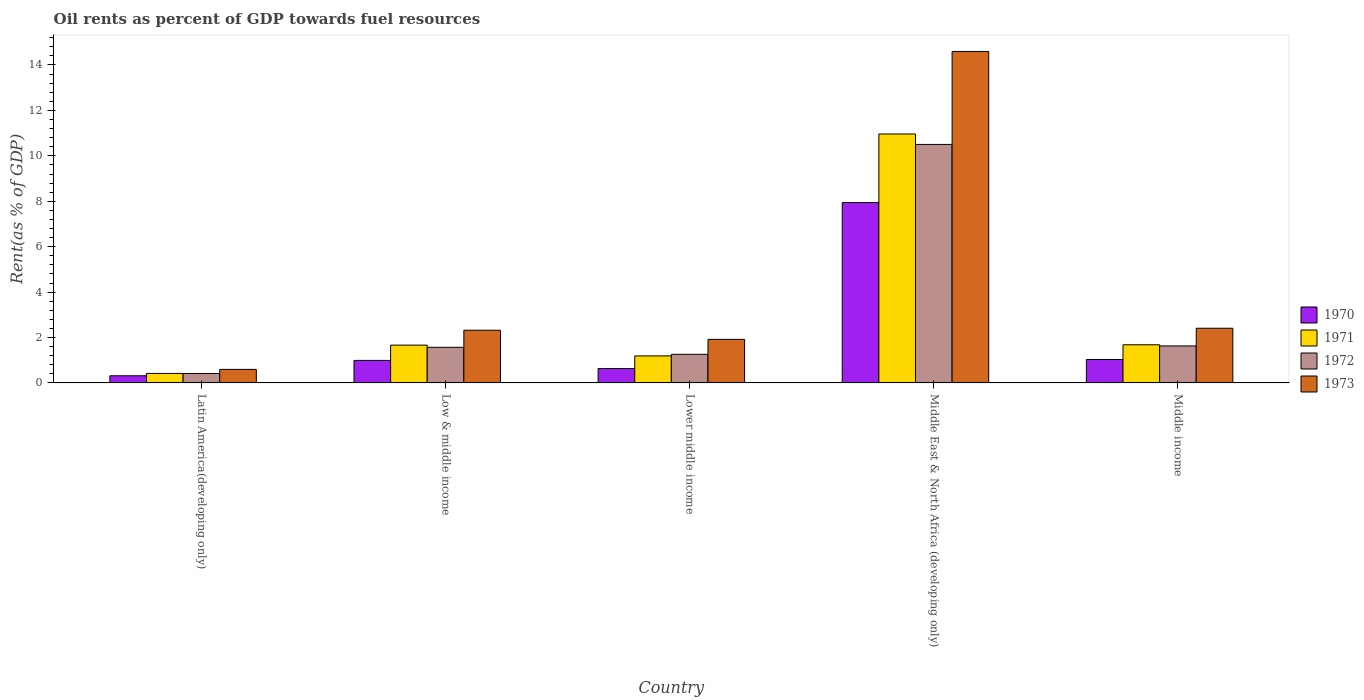Are the number of bars on each tick of the X-axis equal?
Offer a very short reply. Yes. How many bars are there on the 4th tick from the left?
Your answer should be compact. 4. How many bars are there on the 1st tick from the right?
Your response must be concise. 4. What is the oil rent in 1972 in Middle income?
Offer a terse response. 1.63. Across all countries, what is the maximum oil rent in 1971?
Your response must be concise. 10.96. Across all countries, what is the minimum oil rent in 1972?
Offer a very short reply. 0.42. In which country was the oil rent in 1973 maximum?
Your answer should be very brief. Middle East & North Africa (developing only). In which country was the oil rent in 1972 minimum?
Your answer should be compact. Latin America(developing only). What is the total oil rent in 1973 in the graph?
Provide a succinct answer. 21.84. What is the difference between the oil rent in 1970 in Latin America(developing only) and that in Middle East & North Africa (developing only)?
Your answer should be compact. -7.63. What is the difference between the oil rent in 1970 in Latin America(developing only) and the oil rent in 1971 in Low & middle income?
Your response must be concise. -1.35. What is the average oil rent in 1972 per country?
Your answer should be compact. 3.08. What is the difference between the oil rent of/in 1971 and oil rent of/in 1973 in Middle income?
Your response must be concise. -0.73. In how many countries, is the oil rent in 1971 greater than 1.2000000000000002 %?
Your answer should be very brief. 3. What is the ratio of the oil rent in 1973 in Lower middle income to that in Middle income?
Your answer should be very brief. 0.8. Is the oil rent in 1972 in Low & middle income less than that in Lower middle income?
Offer a terse response. No. What is the difference between the highest and the second highest oil rent in 1972?
Make the answer very short. -8.87. What is the difference between the highest and the lowest oil rent in 1972?
Offer a very short reply. 10.09. In how many countries, is the oil rent in 1973 greater than the average oil rent in 1973 taken over all countries?
Keep it short and to the point. 1. What does the 3rd bar from the left in Latin America(developing only) represents?
Ensure brevity in your answer.  1972. What does the 1st bar from the right in Middle income represents?
Offer a terse response. 1973. How many bars are there?
Offer a very short reply. 20. Are all the bars in the graph horizontal?
Offer a terse response. No. How many countries are there in the graph?
Provide a short and direct response. 5. What is the difference between two consecutive major ticks on the Y-axis?
Provide a succinct answer. 2. Does the graph contain any zero values?
Keep it short and to the point. No. How many legend labels are there?
Offer a terse response. 4. How are the legend labels stacked?
Provide a succinct answer. Vertical. What is the title of the graph?
Offer a terse response. Oil rents as percent of GDP towards fuel resources. What is the label or title of the Y-axis?
Provide a short and direct response. Rent(as % of GDP). What is the Rent(as % of GDP) of 1970 in Latin America(developing only)?
Ensure brevity in your answer.  0.32. What is the Rent(as % of GDP) in 1971 in Latin America(developing only)?
Provide a short and direct response. 0.42. What is the Rent(as % of GDP) of 1972 in Latin America(developing only)?
Your answer should be compact. 0.42. What is the Rent(as % of GDP) in 1973 in Latin America(developing only)?
Your answer should be compact. 0.6. What is the Rent(as % of GDP) in 1970 in Low & middle income?
Your response must be concise. 0.99. What is the Rent(as % of GDP) in 1971 in Low & middle income?
Give a very brief answer. 1.67. What is the Rent(as % of GDP) in 1972 in Low & middle income?
Keep it short and to the point. 1.57. What is the Rent(as % of GDP) in 1973 in Low & middle income?
Offer a terse response. 2.32. What is the Rent(as % of GDP) of 1970 in Lower middle income?
Your response must be concise. 0.63. What is the Rent(as % of GDP) of 1971 in Lower middle income?
Keep it short and to the point. 1.19. What is the Rent(as % of GDP) of 1972 in Lower middle income?
Give a very brief answer. 1.26. What is the Rent(as % of GDP) of 1973 in Lower middle income?
Provide a short and direct response. 1.92. What is the Rent(as % of GDP) of 1970 in Middle East & North Africa (developing only)?
Your response must be concise. 7.94. What is the Rent(as % of GDP) in 1971 in Middle East & North Africa (developing only)?
Your answer should be very brief. 10.96. What is the Rent(as % of GDP) of 1972 in Middle East & North Africa (developing only)?
Give a very brief answer. 10.5. What is the Rent(as % of GDP) in 1973 in Middle East & North Africa (developing only)?
Offer a terse response. 14.6. What is the Rent(as % of GDP) of 1970 in Middle income?
Provide a short and direct response. 1.03. What is the Rent(as % of GDP) of 1971 in Middle income?
Provide a short and direct response. 1.68. What is the Rent(as % of GDP) in 1972 in Middle income?
Your answer should be very brief. 1.63. What is the Rent(as % of GDP) in 1973 in Middle income?
Your response must be concise. 2.41. Across all countries, what is the maximum Rent(as % of GDP) in 1970?
Give a very brief answer. 7.94. Across all countries, what is the maximum Rent(as % of GDP) in 1971?
Your response must be concise. 10.96. Across all countries, what is the maximum Rent(as % of GDP) in 1972?
Provide a succinct answer. 10.5. Across all countries, what is the maximum Rent(as % of GDP) of 1973?
Keep it short and to the point. 14.6. Across all countries, what is the minimum Rent(as % of GDP) of 1970?
Provide a succinct answer. 0.32. Across all countries, what is the minimum Rent(as % of GDP) of 1971?
Your response must be concise. 0.42. Across all countries, what is the minimum Rent(as % of GDP) in 1972?
Your answer should be very brief. 0.42. Across all countries, what is the minimum Rent(as % of GDP) of 1973?
Offer a terse response. 0.6. What is the total Rent(as % of GDP) of 1970 in the graph?
Keep it short and to the point. 10.92. What is the total Rent(as % of GDP) in 1971 in the graph?
Provide a short and direct response. 15.92. What is the total Rent(as % of GDP) in 1972 in the graph?
Provide a succinct answer. 15.38. What is the total Rent(as % of GDP) of 1973 in the graph?
Your answer should be compact. 21.84. What is the difference between the Rent(as % of GDP) in 1970 in Latin America(developing only) and that in Low & middle income?
Offer a terse response. -0.68. What is the difference between the Rent(as % of GDP) in 1971 in Latin America(developing only) and that in Low & middle income?
Offer a very short reply. -1.25. What is the difference between the Rent(as % of GDP) of 1972 in Latin America(developing only) and that in Low & middle income?
Your answer should be compact. -1.15. What is the difference between the Rent(as % of GDP) in 1973 in Latin America(developing only) and that in Low & middle income?
Provide a short and direct response. -1.72. What is the difference between the Rent(as % of GDP) in 1970 in Latin America(developing only) and that in Lower middle income?
Your answer should be very brief. -0.32. What is the difference between the Rent(as % of GDP) in 1971 in Latin America(developing only) and that in Lower middle income?
Provide a succinct answer. -0.77. What is the difference between the Rent(as % of GDP) in 1972 in Latin America(developing only) and that in Lower middle income?
Provide a short and direct response. -0.84. What is the difference between the Rent(as % of GDP) of 1973 in Latin America(developing only) and that in Lower middle income?
Offer a terse response. -1.32. What is the difference between the Rent(as % of GDP) of 1970 in Latin America(developing only) and that in Middle East & North Africa (developing only)?
Your response must be concise. -7.63. What is the difference between the Rent(as % of GDP) in 1971 in Latin America(developing only) and that in Middle East & North Africa (developing only)?
Your response must be concise. -10.54. What is the difference between the Rent(as % of GDP) in 1972 in Latin America(developing only) and that in Middle East & North Africa (developing only)?
Give a very brief answer. -10.09. What is the difference between the Rent(as % of GDP) of 1973 in Latin America(developing only) and that in Middle East & North Africa (developing only)?
Offer a very short reply. -14. What is the difference between the Rent(as % of GDP) of 1970 in Latin America(developing only) and that in Middle income?
Make the answer very short. -0.72. What is the difference between the Rent(as % of GDP) in 1971 in Latin America(developing only) and that in Middle income?
Offer a terse response. -1.26. What is the difference between the Rent(as % of GDP) of 1972 in Latin America(developing only) and that in Middle income?
Give a very brief answer. -1.21. What is the difference between the Rent(as % of GDP) of 1973 in Latin America(developing only) and that in Middle income?
Provide a succinct answer. -1.81. What is the difference between the Rent(as % of GDP) of 1970 in Low & middle income and that in Lower middle income?
Give a very brief answer. 0.36. What is the difference between the Rent(as % of GDP) in 1971 in Low & middle income and that in Lower middle income?
Provide a succinct answer. 0.48. What is the difference between the Rent(as % of GDP) of 1972 in Low & middle income and that in Lower middle income?
Your answer should be compact. 0.31. What is the difference between the Rent(as % of GDP) in 1973 in Low & middle income and that in Lower middle income?
Provide a short and direct response. 0.4. What is the difference between the Rent(as % of GDP) of 1970 in Low & middle income and that in Middle East & North Africa (developing only)?
Give a very brief answer. -6.95. What is the difference between the Rent(as % of GDP) of 1971 in Low & middle income and that in Middle East & North Africa (developing only)?
Your response must be concise. -9.3. What is the difference between the Rent(as % of GDP) in 1972 in Low & middle income and that in Middle East & North Africa (developing only)?
Provide a succinct answer. -8.93. What is the difference between the Rent(as % of GDP) of 1973 in Low & middle income and that in Middle East & North Africa (developing only)?
Your answer should be very brief. -12.28. What is the difference between the Rent(as % of GDP) of 1970 in Low & middle income and that in Middle income?
Ensure brevity in your answer.  -0.04. What is the difference between the Rent(as % of GDP) in 1971 in Low & middle income and that in Middle income?
Offer a very short reply. -0.01. What is the difference between the Rent(as % of GDP) in 1972 in Low & middle income and that in Middle income?
Give a very brief answer. -0.06. What is the difference between the Rent(as % of GDP) in 1973 in Low & middle income and that in Middle income?
Your response must be concise. -0.09. What is the difference between the Rent(as % of GDP) of 1970 in Lower middle income and that in Middle East & North Africa (developing only)?
Keep it short and to the point. -7.31. What is the difference between the Rent(as % of GDP) in 1971 in Lower middle income and that in Middle East & North Africa (developing only)?
Ensure brevity in your answer.  -9.77. What is the difference between the Rent(as % of GDP) in 1972 in Lower middle income and that in Middle East & North Africa (developing only)?
Provide a short and direct response. -9.24. What is the difference between the Rent(as % of GDP) in 1973 in Lower middle income and that in Middle East & North Africa (developing only)?
Give a very brief answer. -12.68. What is the difference between the Rent(as % of GDP) of 1970 in Lower middle income and that in Middle income?
Your answer should be compact. -0.4. What is the difference between the Rent(as % of GDP) of 1971 in Lower middle income and that in Middle income?
Provide a short and direct response. -0.49. What is the difference between the Rent(as % of GDP) in 1972 in Lower middle income and that in Middle income?
Make the answer very short. -0.37. What is the difference between the Rent(as % of GDP) of 1973 in Lower middle income and that in Middle income?
Ensure brevity in your answer.  -0.49. What is the difference between the Rent(as % of GDP) of 1970 in Middle East & North Africa (developing only) and that in Middle income?
Give a very brief answer. 6.91. What is the difference between the Rent(as % of GDP) in 1971 in Middle East & North Africa (developing only) and that in Middle income?
Offer a terse response. 9.28. What is the difference between the Rent(as % of GDP) in 1972 in Middle East & North Africa (developing only) and that in Middle income?
Keep it short and to the point. 8.87. What is the difference between the Rent(as % of GDP) of 1973 in Middle East & North Africa (developing only) and that in Middle income?
Your answer should be very brief. 12.19. What is the difference between the Rent(as % of GDP) of 1970 in Latin America(developing only) and the Rent(as % of GDP) of 1971 in Low & middle income?
Offer a very short reply. -1.35. What is the difference between the Rent(as % of GDP) in 1970 in Latin America(developing only) and the Rent(as % of GDP) in 1972 in Low & middle income?
Your answer should be compact. -1.25. What is the difference between the Rent(as % of GDP) in 1970 in Latin America(developing only) and the Rent(as % of GDP) in 1973 in Low & middle income?
Keep it short and to the point. -2.01. What is the difference between the Rent(as % of GDP) of 1971 in Latin America(developing only) and the Rent(as % of GDP) of 1972 in Low & middle income?
Your answer should be compact. -1.15. What is the difference between the Rent(as % of GDP) of 1971 in Latin America(developing only) and the Rent(as % of GDP) of 1973 in Low & middle income?
Give a very brief answer. -1.9. What is the difference between the Rent(as % of GDP) of 1972 in Latin America(developing only) and the Rent(as % of GDP) of 1973 in Low & middle income?
Keep it short and to the point. -1.9. What is the difference between the Rent(as % of GDP) of 1970 in Latin America(developing only) and the Rent(as % of GDP) of 1971 in Lower middle income?
Your answer should be very brief. -0.87. What is the difference between the Rent(as % of GDP) of 1970 in Latin America(developing only) and the Rent(as % of GDP) of 1972 in Lower middle income?
Your answer should be very brief. -0.94. What is the difference between the Rent(as % of GDP) of 1970 in Latin America(developing only) and the Rent(as % of GDP) of 1973 in Lower middle income?
Your answer should be compact. -1.6. What is the difference between the Rent(as % of GDP) of 1971 in Latin America(developing only) and the Rent(as % of GDP) of 1972 in Lower middle income?
Provide a short and direct response. -0.84. What is the difference between the Rent(as % of GDP) of 1971 in Latin America(developing only) and the Rent(as % of GDP) of 1973 in Lower middle income?
Provide a short and direct response. -1.5. What is the difference between the Rent(as % of GDP) in 1972 in Latin America(developing only) and the Rent(as % of GDP) in 1973 in Lower middle income?
Your answer should be very brief. -1.5. What is the difference between the Rent(as % of GDP) of 1970 in Latin America(developing only) and the Rent(as % of GDP) of 1971 in Middle East & North Africa (developing only)?
Provide a short and direct response. -10.65. What is the difference between the Rent(as % of GDP) of 1970 in Latin America(developing only) and the Rent(as % of GDP) of 1972 in Middle East & North Africa (developing only)?
Your answer should be compact. -10.19. What is the difference between the Rent(as % of GDP) in 1970 in Latin America(developing only) and the Rent(as % of GDP) in 1973 in Middle East & North Africa (developing only)?
Your answer should be compact. -14.28. What is the difference between the Rent(as % of GDP) of 1971 in Latin America(developing only) and the Rent(as % of GDP) of 1972 in Middle East & North Africa (developing only)?
Ensure brevity in your answer.  -10.08. What is the difference between the Rent(as % of GDP) of 1971 in Latin America(developing only) and the Rent(as % of GDP) of 1973 in Middle East & North Africa (developing only)?
Make the answer very short. -14.18. What is the difference between the Rent(as % of GDP) in 1972 in Latin America(developing only) and the Rent(as % of GDP) in 1973 in Middle East & North Africa (developing only)?
Make the answer very short. -14.18. What is the difference between the Rent(as % of GDP) of 1970 in Latin America(developing only) and the Rent(as % of GDP) of 1971 in Middle income?
Provide a short and direct response. -1.36. What is the difference between the Rent(as % of GDP) in 1970 in Latin America(developing only) and the Rent(as % of GDP) in 1972 in Middle income?
Provide a short and direct response. -1.32. What is the difference between the Rent(as % of GDP) of 1970 in Latin America(developing only) and the Rent(as % of GDP) of 1973 in Middle income?
Your answer should be very brief. -2.09. What is the difference between the Rent(as % of GDP) of 1971 in Latin America(developing only) and the Rent(as % of GDP) of 1972 in Middle income?
Your answer should be compact. -1.21. What is the difference between the Rent(as % of GDP) of 1971 in Latin America(developing only) and the Rent(as % of GDP) of 1973 in Middle income?
Your response must be concise. -1.99. What is the difference between the Rent(as % of GDP) of 1972 in Latin America(developing only) and the Rent(as % of GDP) of 1973 in Middle income?
Make the answer very short. -1.99. What is the difference between the Rent(as % of GDP) of 1970 in Low & middle income and the Rent(as % of GDP) of 1971 in Lower middle income?
Your response must be concise. -0.2. What is the difference between the Rent(as % of GDP) in 1970 in Low & middle income and the Rent(as % of GDP) in 1972 in Lower middle income?
Give a very brief answer. -0.27. What is the difference between the Rent(as % of GDP) of 1970 in Low & middle income and the Rent(as % of GDP) of 1973 in Lower middle income?
Keep it short and to the point. -0.93. What is the difference between the Rent(as % of GDP) in 1971 in Low & middle income and the Rent(as % of GDP) in 1972 in Lower middle income?
Offer a very short reply. 0.41. What is the difference between the Rent(as % of GDP) of 1971 in Low & middle income and the Rent(as % of GDP) of 1973 in Lower middle income?
Offer a very short reply. -0.25. What is the difference between the Rent(as % of GDP) of 1972 in Low & middle income and the Rent(as % of GDP) of 1973 in Lower middle income?
Your answer should be very brief. -0.35. What is the difference between the Rent(as % of GDP) of 1970 in Low & middle income and the Rent(as % of GDP) of 1971 in Middle East & North Africa (developing only)?
Provide a succinct answer. -9.97. What is the difference between the Rent(as % of GDP) in 1970 in Low & middle income and the Rent(as % of GDP) in 1972 in Middle East & North Africa (developing only)?
Provide a short and direct response. -9.51. What is the difference between the Rent(as % of GDP) of 1970 in Low & middle income and the Rent(as % of GDP) of 1973 in Middle East & North Africa (developing only)?
Your answer should be compact. -13.6. What is the difference between the Rent(as % of GDP) in 1971 in Low & middle income and the Rent(as % of GDP) in 1972 in Middle East & North Africa (developing only)?
Offer a very short reply. -8.84. What is the difference between the Rent(as % of GDP) of 1971 in Low & middle income and the Rent(as % of GDP) of 1973 in Middle East & North Africa (developing only)?
Make the answer very short. -12.93. What is the difference between the Rent(as % of GDP) in 1972 in Low & middle income and the Rent(as % of GDP) in 1973 in Middle East & North Africa (developing only)?
Keep it short and to the point. -13.03. What is the difference between the Rent(as % of GDP) in 1970 in Low & middle income and the Rent(as % of GDP) in 1971 in Middle income?
Your answer should be very brief. -0.69. What is the difference between the Rent(as % of GDP) of 1970 in Low & middle income and the Rent(as % of GDP) of 1972 in Middle income?
Your answer should be compact. -0.64. What is the difference between the Rent(as % of GDP) in 1970 in Low & middle income and the Rent(as % of GDP) in 1973 in Middle income?
Keep it short and to the point. -1.42. What is the difference between the Rent(as % of GDP) in 1971 in Low & middle income and the Rent(as % of GDP) in 1972 in Middle income?
Provide a short and direct response. 0.03. What is the difference between the Rent(as % of GDP) of 1971 in Low & middle income and the Rent(as % of GDP) of 1973 in Middle income?
Offer a terse response. -0.74. What is the difference between the Rent(as % of GDP) of 1972 in Low & middle income and the Rent(as % of GDP) of 1973 in Middle income?
Your response must be concise. -0.84. What is the difference between the Rent(as % of GDP) in 1970 in Lower middle income and the Rent(as % of GDP) in 1971 in Middle East & North Africa (developing only)?
Make the answer very short. -10.33. What is the difference between the Rent(as % of GDP) in 1970 in Lower middle income and the Rent(as % of GDP) in 1972 in Middle East & North Africa (developing only)?
Your response must be concise. -9.87. What is the difference between the Rent(as % of GDP) in 1970 in Lower middle income and the Rent(as % of GDP) in 1973 in Middle East & North Africa (developing only)?
Your answer should be very brief. -13.96. What is the difference between the Rent(as % of GDP) in 1971 in Lower middle income and the Rent(as % of GDP) in 1972 in Middle East & North Africa (developing only)?
Your response must be concise. -9.31. What is the difference between the Rent(as % of GDP) in 1971 in Lower middle income and the Rent(as % of GDP) in 1973 in Middle East & North Africa (developing only)?
Keep it short and to the point. -13.41. What is the difference between the Rent(as % of GDP) in 1972 in Lower middle income and the Rent(as % of GDP) in 1973 in Middle East & North Africa (developing only)?
Your response must be concise. -13.34. What is the difference between the Rent(as % of GDP) in 1970 in Lower middle income and the Rent(as % of GDP) in 1971 in Middle income?
Your answer should be very brief. -1.05. What is the difference between the Rent(as % of GDP) of 1970 in Lower middle income and the Rent(as % of GDP) of 1972 in Middle income?
Provide a succinct answer. -1. What is the difference between the Rent(as % of GDP) of 1970 in Lower middle income and the Rent(as % of GDP) of 1973 in Middle income?
Provide a short and direct response. -1.77. What is the difference between the Rent(as % of GDP) of 1971 in Lower middle income and the Rent(as % of GDP) of 1972 in Middle income?
Ensure brevity in your answer.  -0.44. What is the difference between the Rent(as % of GDP) in 1971 in Lower middle income and the Rent(as % of GDP) in 1973 in Middle income?
Provide a short and direct response. -1.22. What is the difference between the Rent(as % of GDP) in 1972 in Lower middle income and the Rent(as % of GDP) in 1973 in Middle income?
Ensure brevity in your answer.  -1.15. What is the difference between the Rent(as % of GDP) in 1970 in Middle East & North Africa (developing only) and the Rent(as % of GDP) in 1971 in Middle income?
Make the answer very short. 6.26. What is the difference between the Rent(as % of GDP) in 1970 in Middle East & North Africa (developing only) and the Rent(as % of GDP) in 1972 in Middle income?
Offer a terse response. 6.31. What is the difference between the Rent(as % of GDP) in 1970 in Middle East & North Africa (developing only) and the Rent(as % of GDP) in 1973 in Middle income?
Your answer should be compact. 5.53. What is the difference between the Rent(as % of GDP) in 1971 in Middle East & North Africa (developing only) and the Rent(as % of GDP) in 1972 in Middle income?
Make the answer very short. 9.33. What is the difference between the Rent(as % of GDP) of 1971 in Middle East & North Africa (developing only) and the Rent(as % of GDP) of 1973 in Middle income?
Offer a terse response. 8.55. What is the difference between the Rent(as % of GDP) in 1972 in Middle East & North Africa (developing only) and the Rent(as % of GDP) in 1973 in Middle income?
Offer a terse response. 8.09. What is the average Rent(as % of GDP) of 1970 per country?
Ensure brevity in your answer.  2.18. What is the average Rent(as % of GDP) in 1971 per country?
Your answer should be very brief. 3.18. What is the average Rent(as % of GDP) in 1972 per country?
Provide a short and direct response. 3.08. What is the average Rent(as % of GDP) in 1973 per country?
Your response must be concise. 4.37. What is the difference between the Rent(as % of GDP) in 1970 and Rent(as % of GDP) in 1971 in Latin America(developing only)?
Ensure brevity in your answer.  -0.1. What is the difference between the Rent(as % of GDP) of 1970 and Rent(as % of GDP) of 1972 in Latin America(developing only)?
Make the answer very short. -0.1. What is the difference between the Rent(as % of GDP) in 1970 and Rent(as % of GDP) in 1973 in Latin America(developing only)?
Give a very brief answer. -0.28. What is the difference between the Rent(as % of GDP) of 1971 and Rent(as % of GDP) of 1972 in Latin America(developing only)?
Provide a succinct answer. 0. What is the difference between the Rent(as % of GDP) of 1971 and Rent(as % of GDP) of 1973 in Latin America(developing only)?
Keep it short and to the point. -0.18. What is the difference between the Rent(as % of GDP) in 1972 and Rent(as % of GDP) in 1973 in Latin America(developing only)?
Provide a short and direct response. -0.18. What is the difference between the Rent(as % of GDP) in 1970 and Rent(as % of GDP) in 1971 in Low & middle income?
Offer a very short reply. -0.67. What is the difference between the Rent(as % of GDP) in 1970 and Rent(as % of GDP) in 1972 in Low & middle income?
Give a very brief answer. -0.58. What is the difference between the Rent(as % of GDP) in 1970 and Rent(as % of GDP) in 1973 in Low & middle income?
Your response must be concise. -1.33. What is the difference between the Rent(as % of GDP) of 1971 and Rent(as % of GDP) of 1972 in Low & middle income?
Make the answer very short. 0.1. What is the difference between the Rent(as % of GDP) of 1971 and Rent(as % of GDP) of 1973 in Low & middle income?
Provide a succinct answer. -0.66. What is the difference between the Rent(as % of GDP) in 1972 and Rent(as % of GDP) in 1973 in Low & middle income?
Keep it short and to the point. -0.75. What is the difference between the Rent(as % of GDP) in 1970 and Rent(as % of GDP) in 1971 in Lower middle income?
Make the answer very short. -0.56. What is the difference between the Rent(as % of GDP) of 1970 and Rent(as % of GDP) of 1972 in Lower middle income?
Ensure brevity in your answer.  -0.62. What is the difference between the Rent(as % of GDP) in 1970 and Rent(as % of GDP) in 1973 in Lower middle income?
Keep it short and to the point. -1.28. What is the difference between the Rent(as % of GDP) of 1971 and Rent(as % of GDP) of 1972 in Lower middle income?
Your response must be concise. -0.07. What is the difference between the Rent(as % of GDP) of 1971 and Rent(as % of GDP) of 1973 in Lower middle income?
Provide a succinct answer. -0.73. What is the difference between the Rent(as % of GDP) of 1972 and Rent(as % of GDP) of 1973 in Lower middle income?
Your answer should be compact. -0.66. What is the difference between the Rent(as % of GDP) in 1970 and Rent(as % of GDP) in 1971 in Middle East & North Africa (developing only)?
Your answer should be very brief. -3.02. What is the difference between the Rent(as % of GDP) of 1970 and Rent(as % of GDP) of 1972 in Middle East & North Africa (developing only)?
Ensure brevity in your answer.  -2.56. What is the difference between the Rent(as % of GDP) of 1970 and Rent(as % of GDP) of 1973 in Middle East & North Africa (developing only)?
Provide a short and direct response. -6.65. What is the difference between the Rent(as % of GDP) in 1971 and Rent(as % of GDP) in 1972 in Middle East & North Africa (developing only)?
Keep it short and to the point. 0.46. What is the difference between the Rent(as % of GDP) of 1971 and Rent(as % of GDP) of 1973 in Middle East & North Africa (developing only)?
Keep it short and to the point. -3.63. What is the difference between the Rent(as % of GDP) of 1972 and Rent(as % of GDP) of 1973 in Middle East & North Africa (developing only)?
Ensure brevity in your answer.  -4.09. What is the difference between the Rent(as % of GDP) in 1970 and Rent(as % of GDP) in 1971 in Middle income?
Offer a very short reply. -0.65. What is the difference between the Rent(as % of GDP) in 1970 and Rent(as % of GDP) in 1972 in Middle income?
Make the answer very short. -0.6. What is the difference between the Rent(as % of GDP) of 1970 and Rent(as % of GDP) of 1973 in Middle income?
Keep it short and to the point. -1.38. What is the difference between the Rent(as % of GDP) of 1971 and Rent(as % of GDP) of 1972 in Middle income?
Offer a terse response. 0.05. What is the difference between the Rent(as % of GDP) in 1971 and Rent(as % of GDP) in 1973 in Middle income?
Your response must be concise. -0.73. What is the difference between the Rent(as % of GDP) of 1972 and Rent(as % of GDP) of 1973 in Middle income?
Offer a very short reply. -0.78. What is the ratio of the Rent(as % of GDP) in 1970 in Latin America(developing only) to that in Low & middle income?
Offer a terse response. 0.32. What is the ratio of the Rent(as % of GDP) in 1971 in Latin America(developing only) to that in Low & middle income?
Give a very brief answer. 0.25. What is the ratio of the Rent(as % of GDP) in 1972 in Latin America(developing only) to that in Low & middle income?
Your answer should be very brief. 0.27. What is the ratio of the Rent(as % of GDP) of 1973 in Latin America(developing only) to that in Low & middle income?
Offer a terse response. 0.26. What is the ratio of the Rent(as % of GDP) of 1970 in Latin America(developing only) to that in Lower middle income?
Offer a terse response. 0.5. What is the ratio of the Rent(as % of GDP) in 1971 in Latin America(developing only) to that in Lower middle income?
Give a very brief answer. 0.35. What is the ratio of the Rent(as % of GDP) in 1972 in Latin America(developing only) to that in Lower middle income?
Give a very brief answer. 0.33. What is the ratio of the Rent(as % of GDP) in 1973 in Latin America(developing only) to that in Lower middle income?
Keep it short and to the point. 0.31. What is the ratio of the Rent(as % of GDP) of 1970 in Latin America(developing only) to that in Middle East & North Africa (developing only)?
Make the answer very short. 0.04. What is the ratio of the Rent(as % of GDP) in 1971 in Latin America(developing only) to that in Middle East & North Africa (developing only)?
Your response must be concise. 0.04. What is the ratio of the Rent(as % of GDP) of 1972 in Latin America(developing only) to that in Middle East & North Africa (developing only)?
Keep it short and to the point. 0.04. What is the ratio of the Rent(as % of GDP) of 1973 in Latin America(developing only) to that in Middle East & North Africa (developing only)?
Your answer should be compact. 0.04. What is the ratio of the Rent(as % of GDP) of 1970 in Latin America(developing only) to that in Middle income?
Your answer should be very brief. 0.31. What is the ratio of the Rent(as % of GDP) in 1971 in Latin America(developing only) to that in Middle income?
Your answer should be compact. 0.25. What is the ratio of the Rent(as % of GDP) in 1972 in Latin America(developing only) to that in Middle income?
Make the answer very short. 0.26. What is the ratio of the Rent(as % of GDP) in 1973 in Latin America(developing only) to that in Middle income?
Give a very brief answer. 0.25. What is the ratio of the Rent(as % of GDP) of 1970 in Low & middle income to that in Lower middle income?
Provide a succinct answer. 1.56. What is the ratio of the Rent(as % of GDP) in 1971 in Low & middle income to that in Lower middle income?
Make the answer very short. 1.4. What is the ratio of the Rent(as % of GDP) in 1972 in Low & middle income to that in Lower middle income?
Provide a short and direct response. 1.25. What is the ratio of the Rent(as % of GDP) of 1973 in Low & middle income to that in Lower middle income?
Give a very brief answer. 1.21. What is the ratio of the Rent(as % of GDP) in 1970 in Low & middle income to that in Middle East & North Africa (developing only)?
Ensure brevity in your answer.  0.12. What is the ratio of the Rent(as % of GDP) of 1971 in Low & middle income to that in Middle East & North Africa (developing only)?
Your answer should be very brief. 0.15. What is the ratio of the Rent(as % of GDP) in 1972 in Low & middle income to that in Middle East & North Africa (developing only)?
Provide a succinct answer. 0.15. What is the ratio of the Rent(as % of GDP) of 1973 in Low & middle income to that in Middle East & North Africa (developing only)?
Your response must be concise. 0.16. What is the ratio of the Rent(as % of GDP) of 1972 in Low & middle income to that in Middle income?
Give a very brief answer. 0.96. What is the ratio of the Rent(as % of GDP) in 1973 in Low & middle income to that in Middle income?
Provide a short and direct response. 0.96. What is the ratio of the Rent(as % of GDP) of 1970 in Lower middle income to that in Middle East & North Africa (developing only)?
Provide a succinct answer. 0.08. What is the ratio of the Rent(as % of GDP) of 1971 in Lower middle income to that in Middle East & North Africa (developing only)?
Ensure brevity in your answer.  0.11. What is the ratio of the Rent(as % of GDP) in 1972 in Lower middle income to that in Middle East & North Africa (developing only)?
Your answer should be very brief. 0.12. What is the ratio of the Rent(as % of GDP) of 1973 in Lower middle income to that in Middle East & North Africa (developing only)?
Offer a terse response. 0.13. What is the ratio of the Rent(as % of GDP) of 1970 in Lower middle income to that in Middle income?
Provide a succinct answer. 0.61. What is the ratio of the Rent(as % of GDP) in 1971 in Lower middle income to that in Middle income?
Your answer should be very brief. 0.71. What is the ratio of the Rent(as % of GDP) of 1972 in Lower middle income to that in Middle income?
Your response must be concise. 0.77. What is the ratio of the Rent(as % of GDP) in 1973 in Lower middle income to that in Middle income?
Provide a short and direct response. 0.8. What is the ratio of the Rent(as % of GDP) in 1970 in Middle East & North Africa (developing only) to that in Middle income?
Ensure brevity in your answer.  7.69. What is the ratio of the Rent(as % of GDP) of 1971 in Middle East & North Africa (developing only) to that in Middle income?
Make the answer very short. 6.52. What is the ratio of the Rent(as % of GDP) in 1972 in Middle East & North Africa (developing only) to that in Middle income?
Ensure brevity in your answer.  6.44. What is the ratio of the Rent(as % of GDP) of 1973 in Middle East & North Africa (developing only) to that in Middle income?
Your answer should be very brief. 6.06. What is the difference between the highest and the second highest Rent(as % of GDP) in 1970?
Your answer should be very brief. 6.91. What is the difference between the highest and the second highest Rent(as % of GDP) of 1971?
Give a very brief answer. 9.28. What is the difference between the highest and the second highest Rent(as % of GDP) in 1972?
Offer a terse response. 8.87. What is the difference between the highest and the second highest Rent(as % of GDP) in 1973?
Provide a succinct answer. 12.19. What is the difference between the highest and the lowest Rent(as % of GDP) of 1970?
Keep it short and to the point. 7.63. What is the difference between the highest and the lowest Rent(as % of GDP) of 1971?
Provide a short and direct response. 10.54. What is the difference between the highest and the lowest Rent(as % of GDP) in 1972?
Ensure brevity in your answer.  10.09. What is the difference between the highest and the lowest Rent(as % of GDP) of 1973?
Provide a succinct answer. 14. 